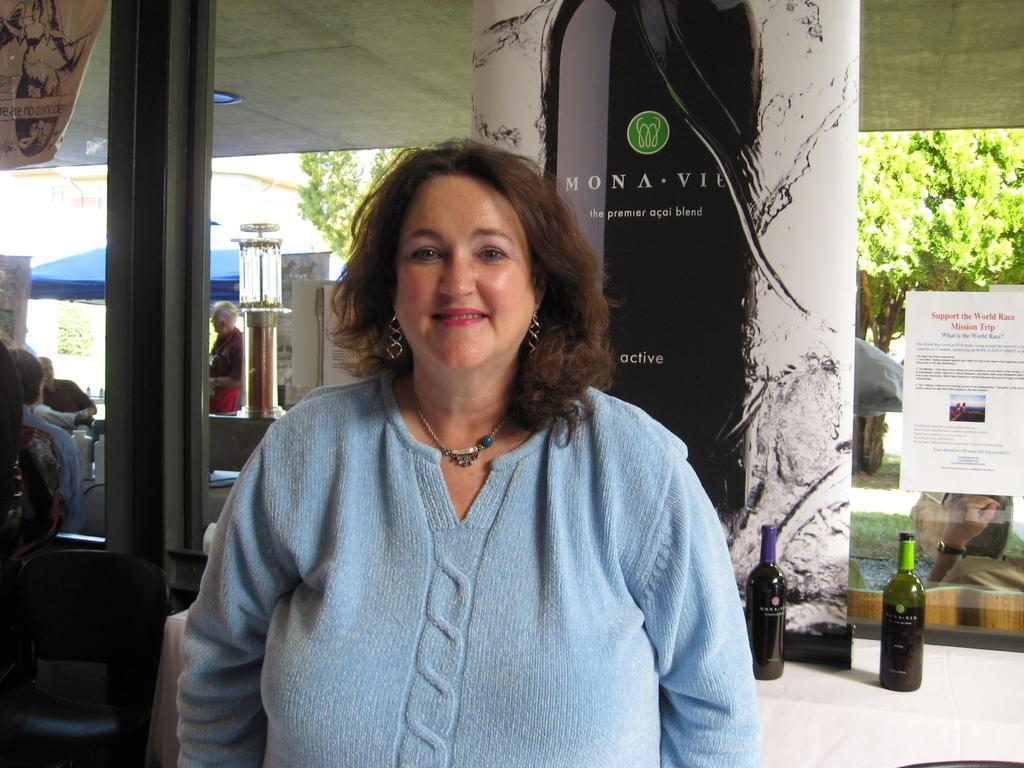In one or two sentences, can you explain what this image depicts? In the center we can see one woman is standing and she is smiling which we can see on her face. And beside her we can see two wine bottles,and some banners. Coming to the background there were some trees and we can see few peoples. 